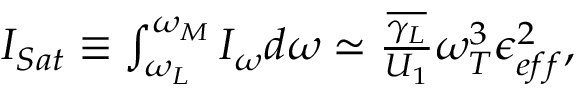<formula> <loc_0><loc_0><loc_500><loc_500>\begin{array} { r } { I _ { S a t } \equiv \int _ { \omega _ { L } } ^ { \omega _ { M } } I _ { \omega } d \omega \simeq \frac { \overline { { \gamma _ { L } } } } { U _ { 1 } } \omega _ { T } ^ { 3 } \epsilon _ { e f f } ^ { 2 } , } \end{array}</formula> 